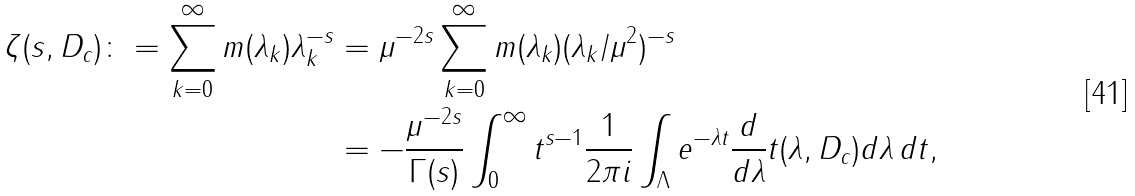Convert formula to latex. <formula><loc_0><loc_0><loc_500><loc_500>\zeta ( s , D _ { c } ) \colon = \sum _ { k = 0 } ^ { \infty } m ( \lambda _ { k } ) \lambda _ { k } ^ { - s } & = \mu ^ { - 2 s } \sum _ { k = 0 } ^ { \infty } m ( \lambda _ { k } ) ( \lambda _ { k } / \mu ^ { 2 } ) ^ { - s } \\ & = - \frac { \mu ^ { - 2 s } } { \Gamma ( s ) } \int _ { 0 } ^ { \infty } t ^ { s - 1 } \frac { 1 } { 2 \pi i } \int _ { \Lambda } e ^ { - \lambda t } \frac { d } { d \lambda } t ( \lambda , D _ { c } ) d \lambda \, d t ,</formula> 